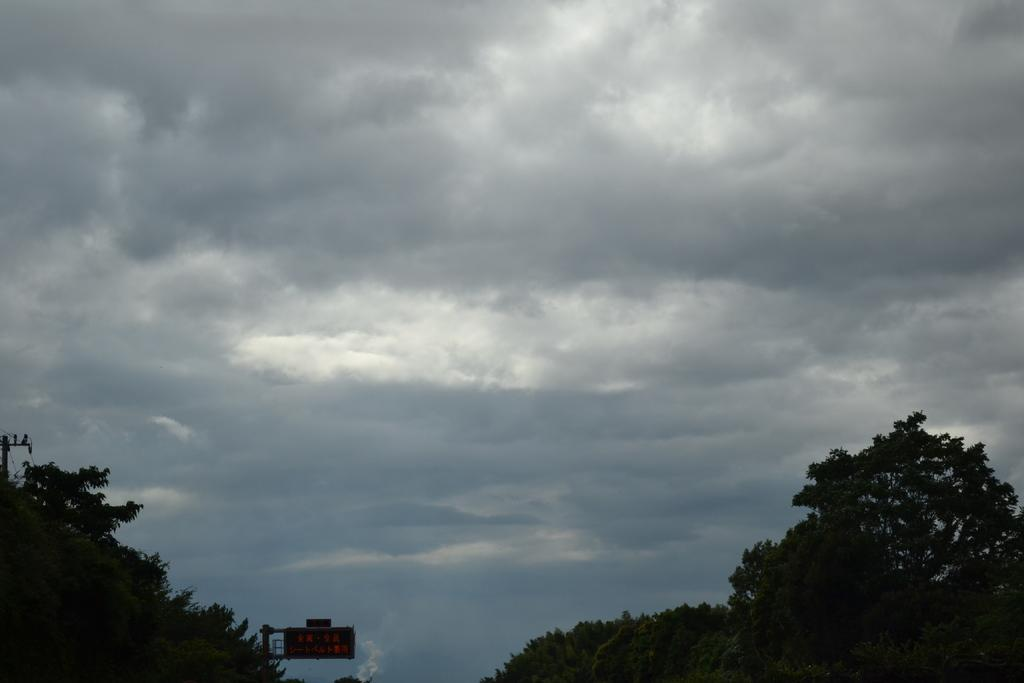What is located at the bottom of the image? There are trees, poles, wires, and a board at the bottom of the image. What can be seen connecting the poles at the bottom of the image? Wires are present at the bottom of the image, connecting the poles. What is visible in the sky in the background of the image? Clouds are present in the sky in the background of the image. Where is the honey stored in the image? There is no honey present in the image. What type of bottle is visible in the image? There is no bottle present in the image. 